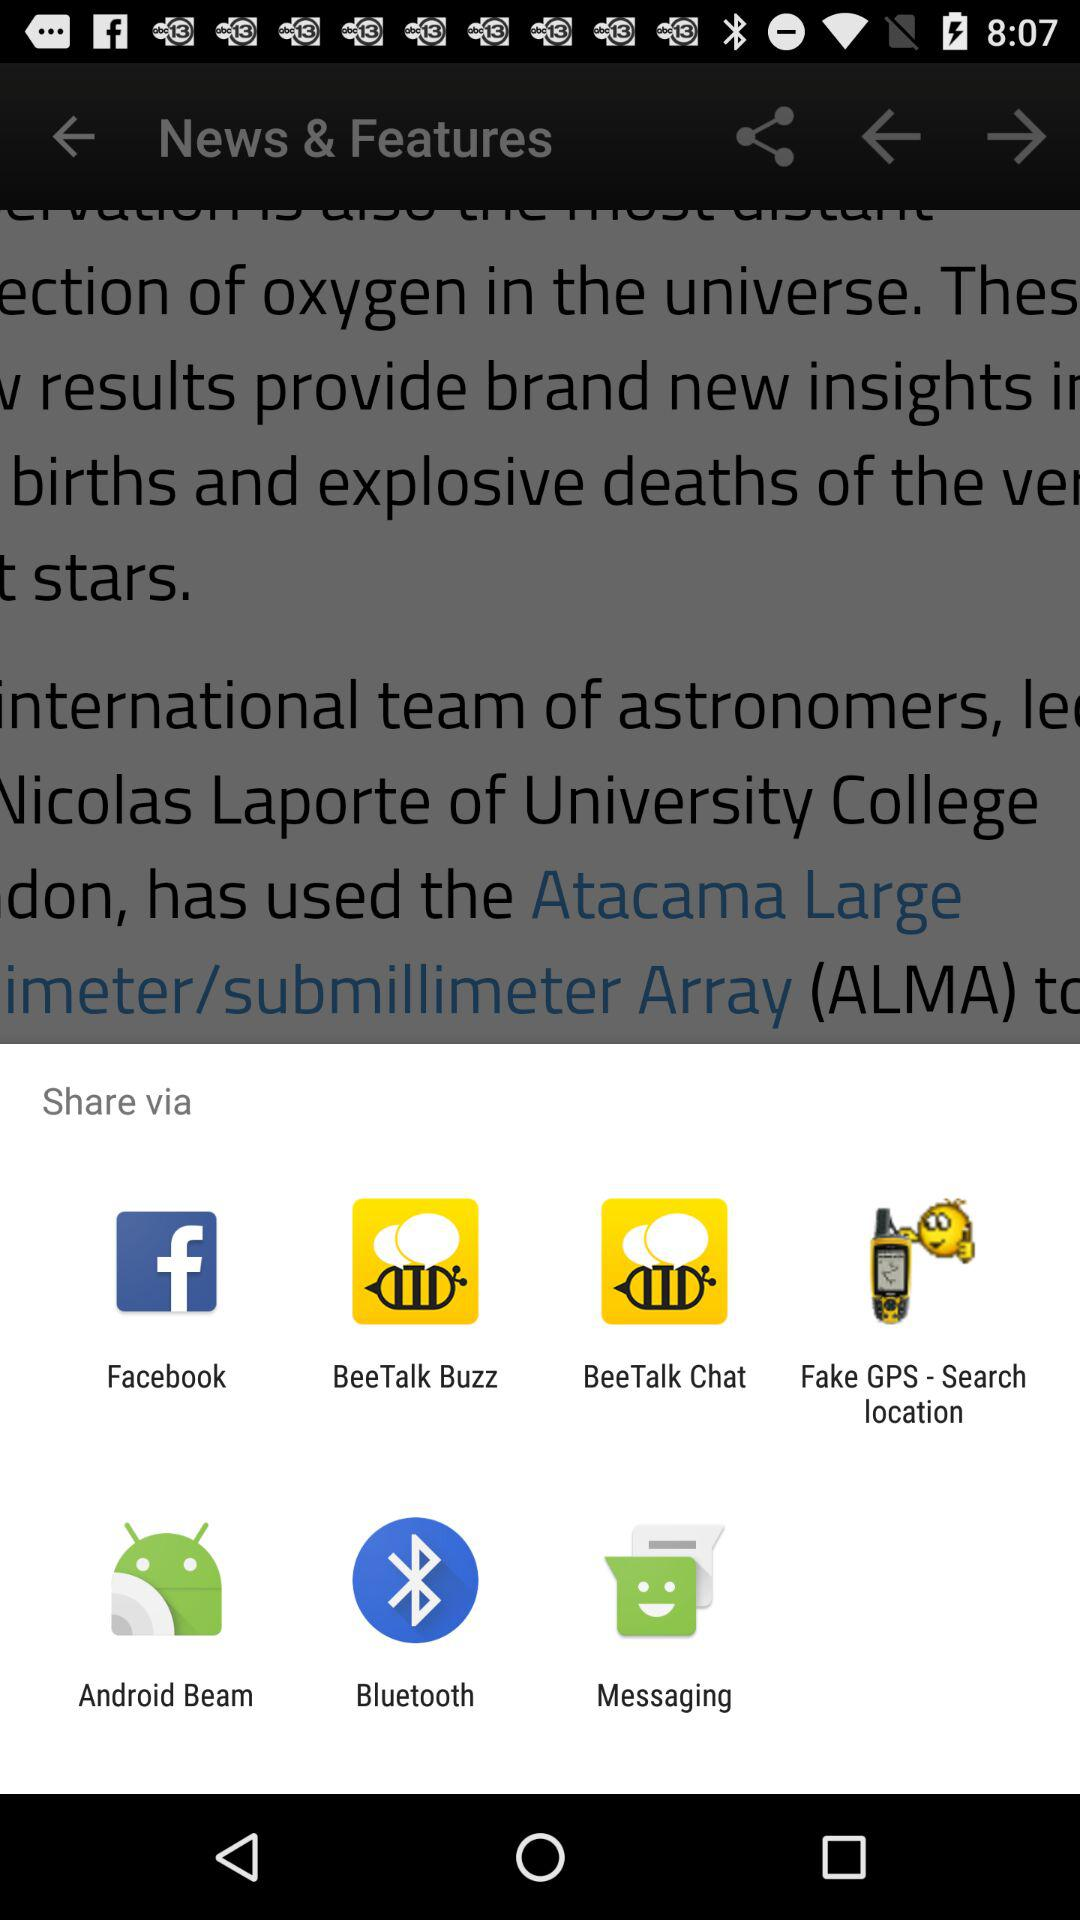What applications can be used to share? The applications are "Facebook", "BeeTalk Buzz", "BeeTalk Chat", "Fake GPS-Search location", "Android Beam", "Bluetooth" and "Messaging". 